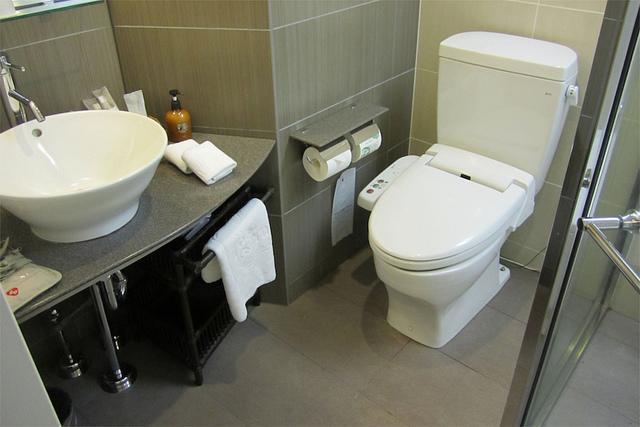How many sinks are there?
Give a very brief answer. 1. How many beds are shown?
Give a very brief answer. 0. 